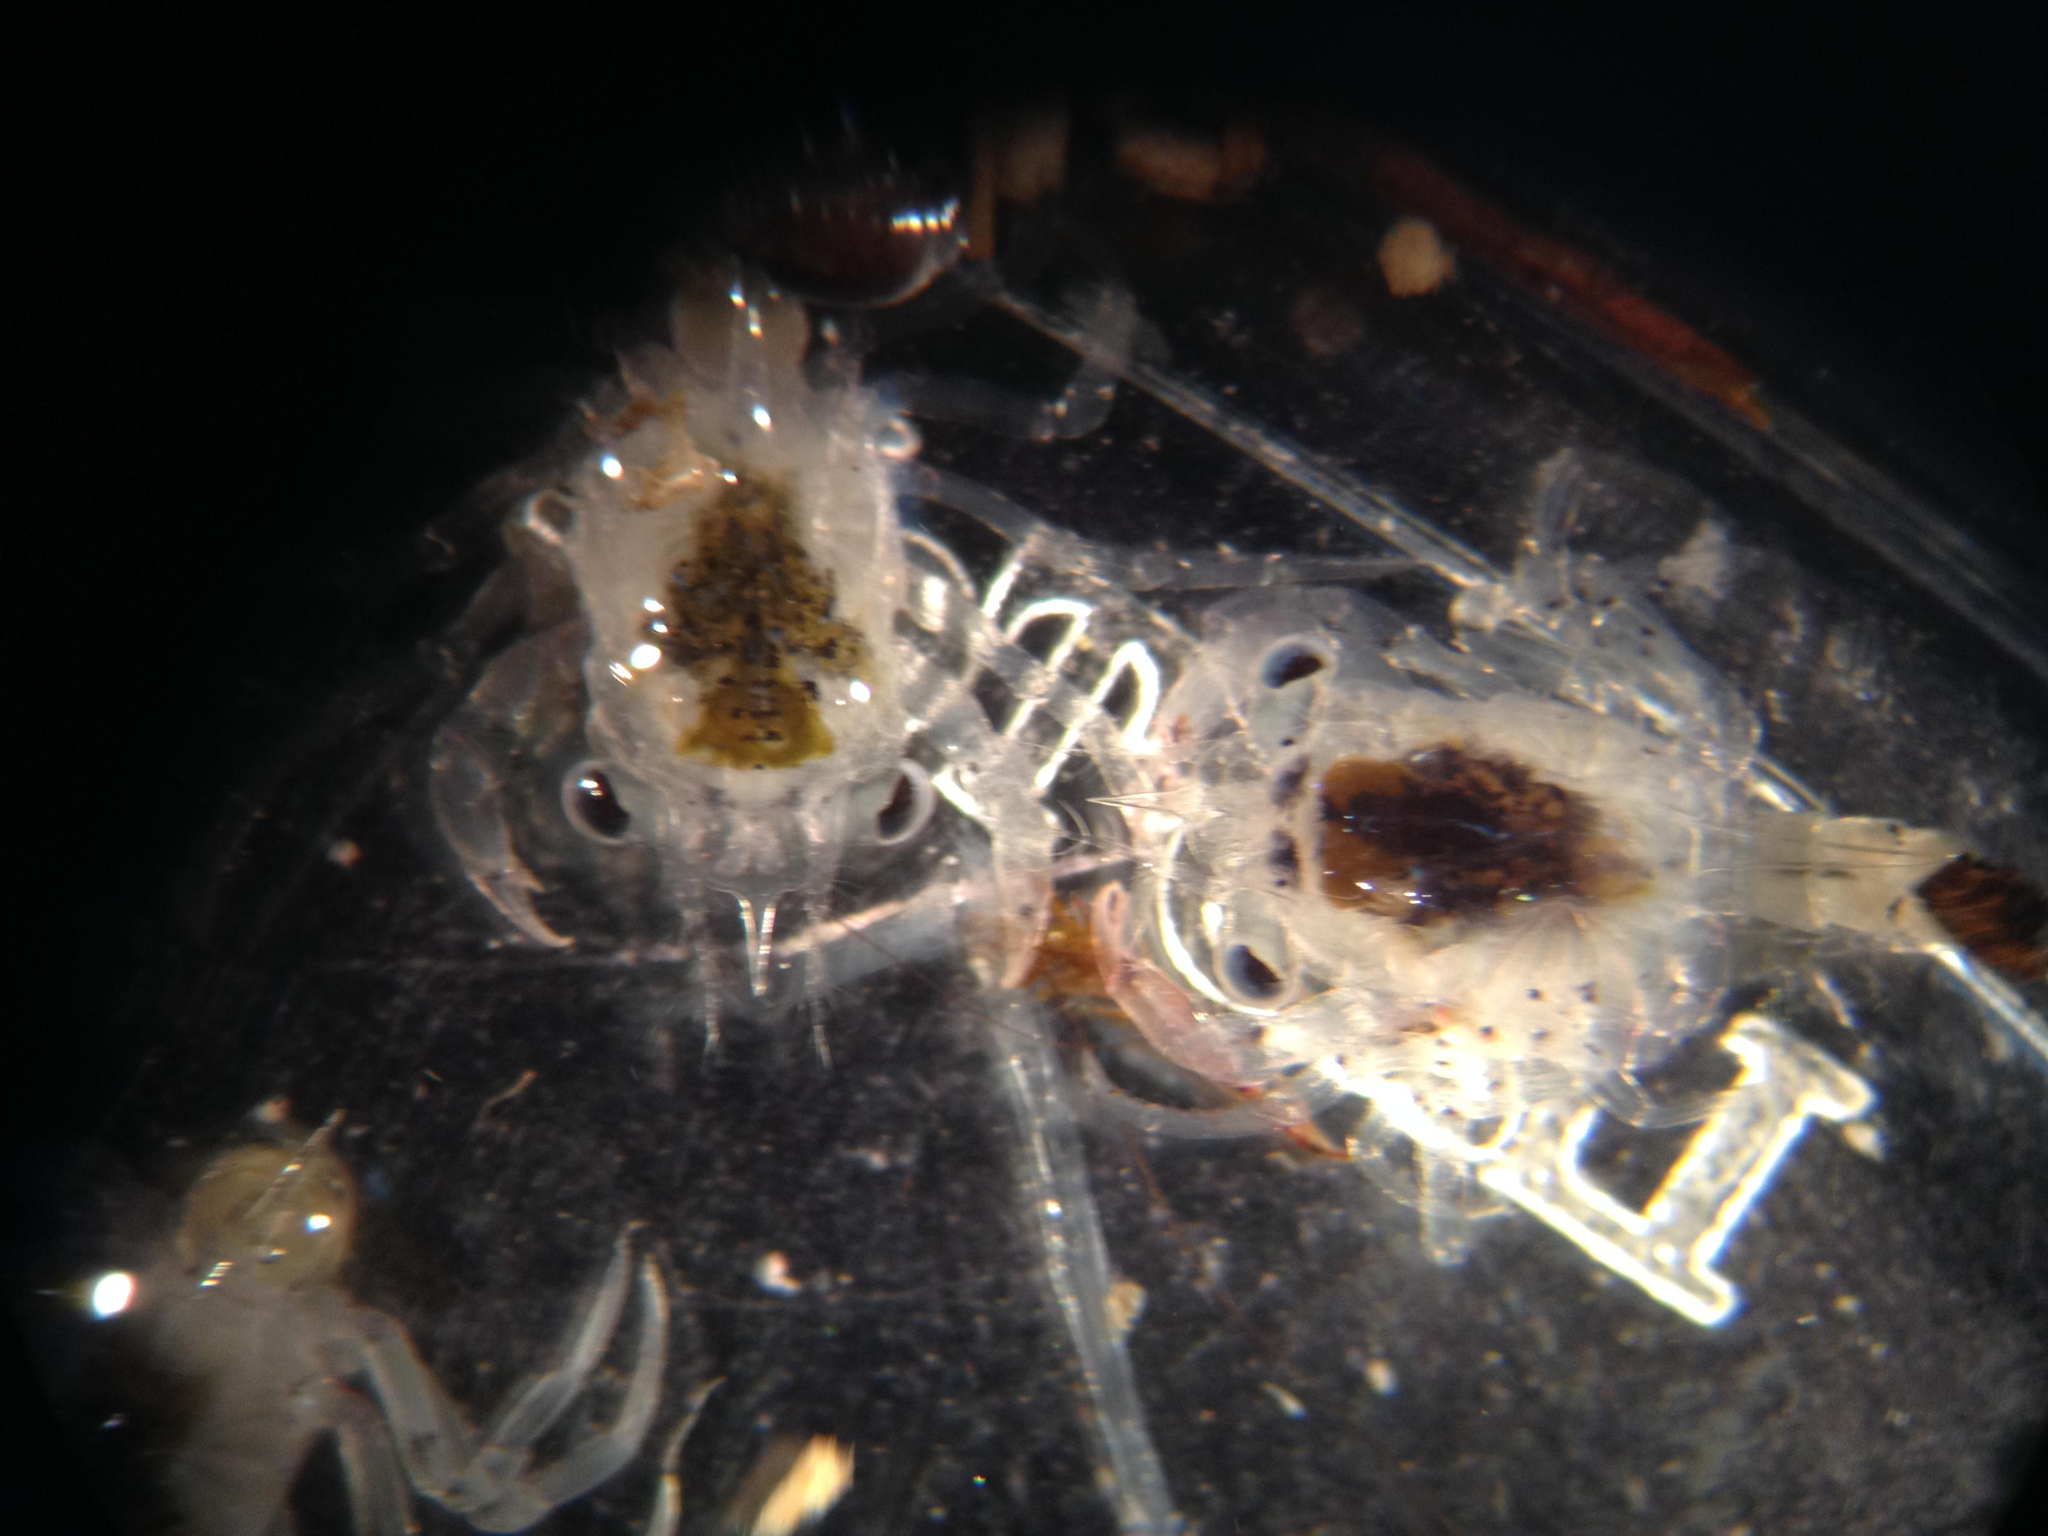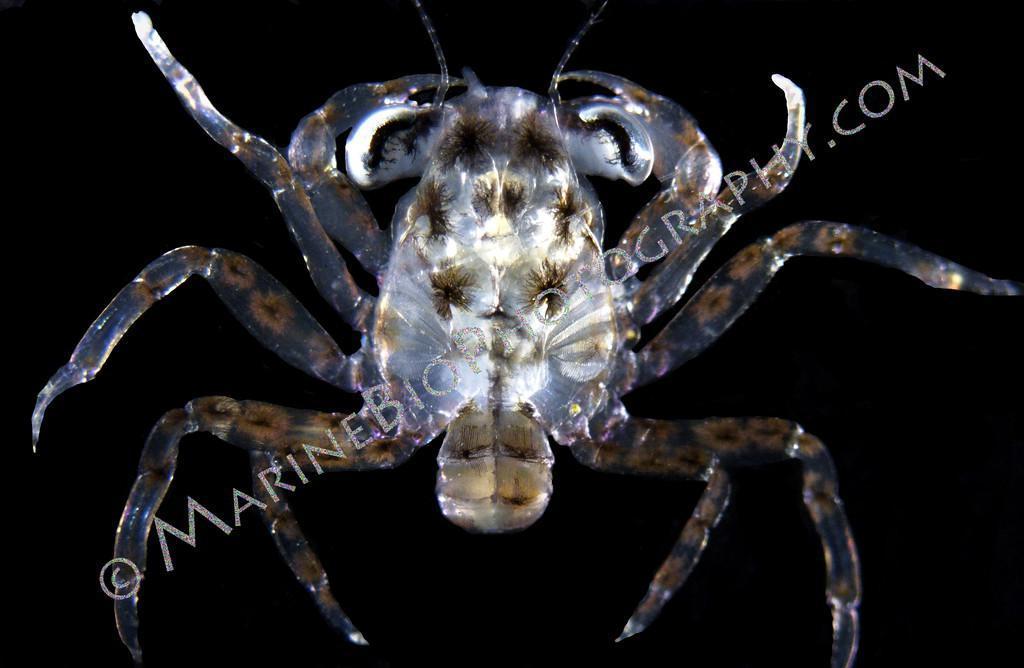The first image is the image on the left, the second image is the image on the right. Given the left and right images, does the statement "Each image contains one many-legged creature, but the creatures depicted on the left and right do not have the same body shape and are not facing in the same direction." hold true? Answer yes or no. No. 